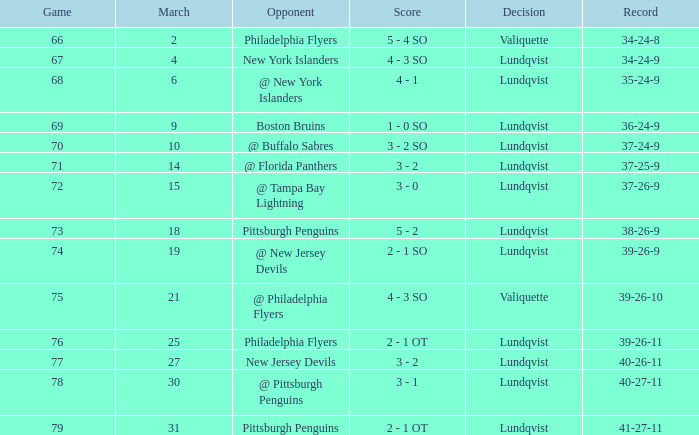Would you be able to parse every entry in this table? {'header': ['Game', 'March', 'Opponent', 'Score', 'Decision', 'Record'], 'rows': [['66', '2', 'Philadelphia Flyers', '5 - 4 SO', 'Valiquette', '34-24-8'], ['67', '4', 'New York Islanders', '4 - 3 SO', 'Lundqvist', '34-24-9'], ['68', '6', '@ New York Islanders', '4 - 1', 'Lundqvist', '35-24-9'], ['69', '9', 'Boston Bruins', '1 - 0 SO', 'Lundqvist', '36-24-9'], ['70', '10', '@ Buffalo Sabres', '3 - 2 SO', 'Lundqvist', '37-24-9'], ['71', '14', '@ Florida Panthers', '3 - 2', 'Lundqvist', '37-25-9'], ['72', '15', '@ Tampa Bay Lightning', '3 - 0', 'Lundqvist', '37-26-9'], ['73', '18', 'Pittsburgh Penguins', '5 - 2', 'Lundqvist', '38-26-9'], ['74', '19', '@ New Jersey Devils', '2 - 1 SO', 'Lundqvist', '39-26-9'], ['75', '21', '@ Philadelphia Flyers', '4 - 3 SO', 'Valiquette', '39-26-10'], ['76', '25', 'Philadelphia Flyers', '2 - 1 OT', 'Lundqvist', '39-26-11'], ['77', '27', 'New Jersey Devils', '3 - 2', 'Lundqvist', '40-26-11'], ['78', '30', '@ Pittsburgh Penguins', '3 - 1', 'Lundqvist', '40-27-11'], ['79', '31', 'Pittsburgh Penguins', '2 - 1 OT', 'Lundqvist', '41-27-11']]} Which score's game was less than 69 when the march was bigger than 2 and the opponents were the New York Islanders? 4 - 3 SO. 